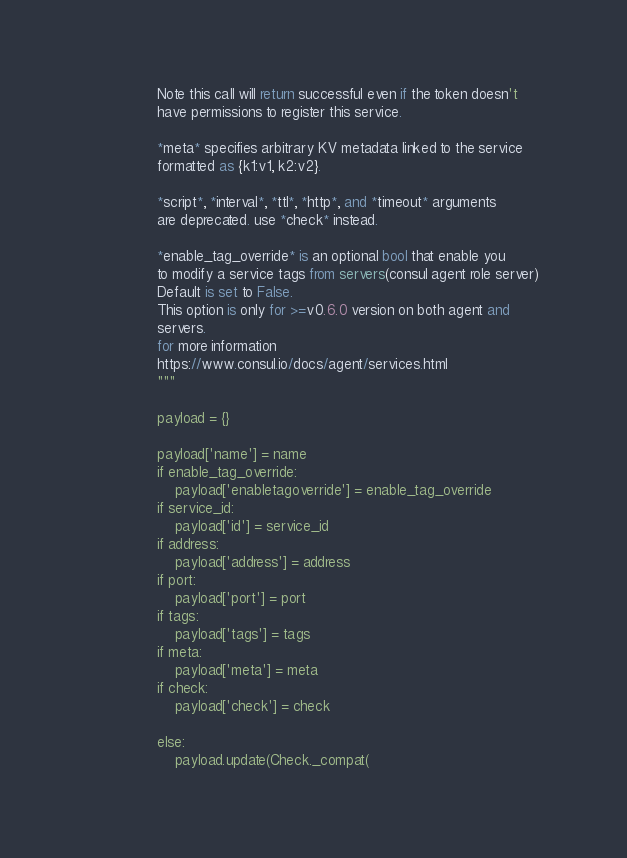<code> <loc_0><loc_0><loc_500><loc_500><_Python_>                Note this call will return successful even if the token doesn't
                have permissions to register this service.

                *meta* specifies arbitrary KV metadata linked to the service
                formatted as {k1:v1, k2:v2}.

                *script*, *interval*, *ttl*, *http*, and *timeout* arguments
                are deprecated. use *check* instead.

                *enable_tag_override* is an optional bool that enable you
                to modify a service tags from servers(consul agent role server)
                Default is set to False.
                This option is only for >=v0.6.0 version on both agent and
                servers.
                for more information
                https://www.consul.io/docs/agent/services.html
                """

                payload = {}

                payload['name'] = name
                if enable_tag_override:
                    payload['enabletagoverride'] = enable_tag_override
                if service_id:
                    payload['id'] = service_id
                if address:
                    payload['address'] = address
                if port:
                    payload['port'] = port
                if tags:
                    payload['tags'] = tags
                if meta:
                    payload['meta'] = meta
                if check:
                    payload['check'] = check

                else:
                    payload.update(Check._compat(</code> 